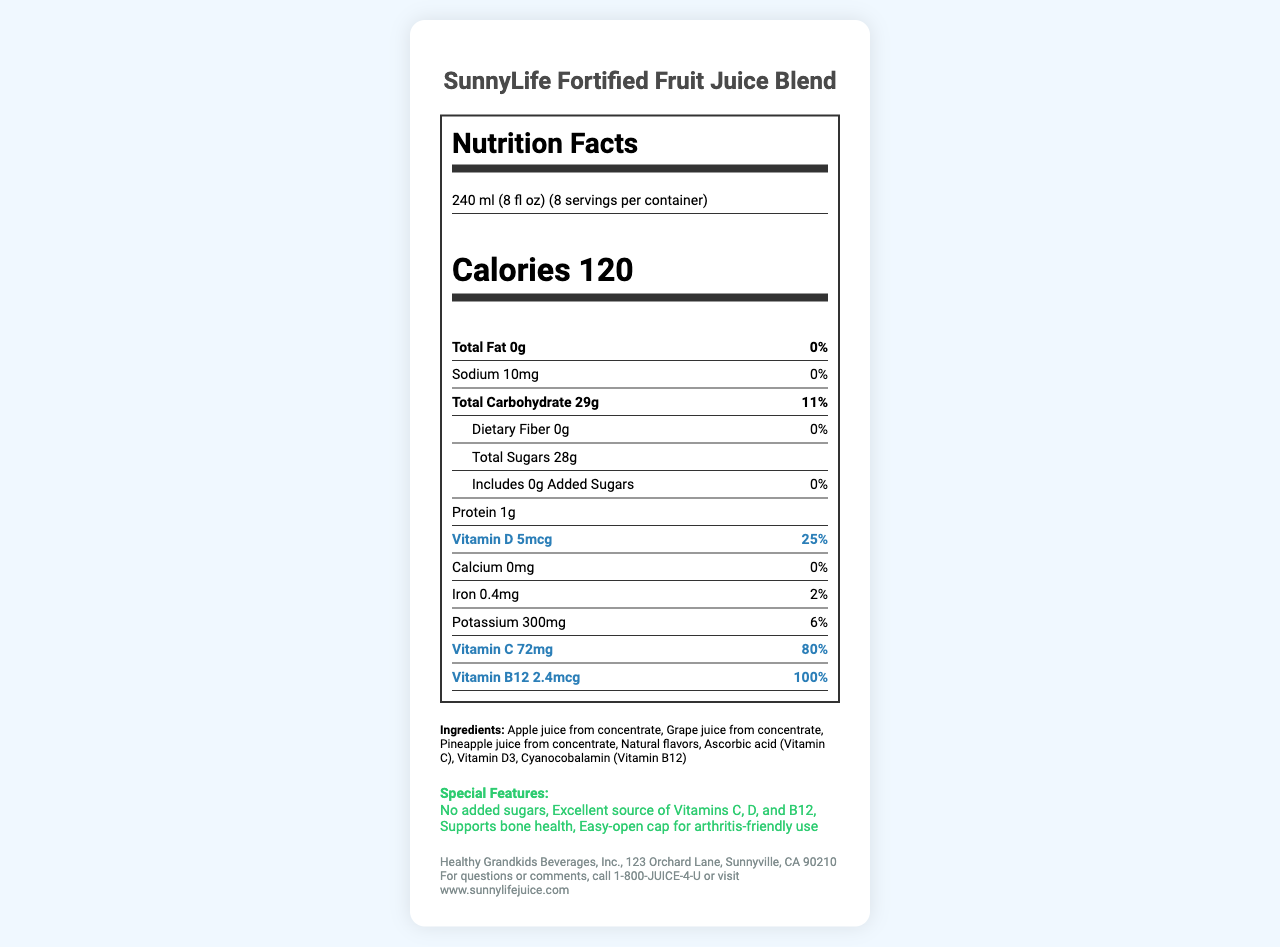what is the serving size for the SunnyLife Fortified Fruit Juice Blend? The document specifies that the serving size is 240 ml (8 fl oz).
Answer: 240 ml (8 fl oz) How many servings are there per container? According to the document, there are 8 servings per container.
Answer: 8 How many calories are in one serving of the juice? The document states that a serving has 120 calories.
Answer: 120 What is the daily value percentage for Vitamin C in each serving? The document shows that each serving provides 80% of the daily value for Vitamin C.
Answer: 80% Are there any added sugars in this juice? The document lists "addedSugars" as 0g with a daily value of 0%.
Answer: No Which vitamins are highlighted for their health benefits in the juice? A. Vitamin A and Vitamin E B. Vitamin C and Vitamin B6 C. Vitamin D and Vitamin B12 The document highlights Vitamin D and Vitamin B12 for their bone health benefits.
Answer: C How much sodium is in each serving of the juice? A. 0 mg B. 10 mg C. 5 mg The document indicates that each serving contains 10 mg of sodium.
Answer: B Is there any dietary fiber in this juice? According to the document, the dietary fiber amount is 0g.
Answer: No Does the juice support bone health? The document mentions that the juice supports bone health as one of its special features.
Answer: Yes How long should the juice be consumed after opening? The storage instructions specify that the juice should be consumed within 7 days after opening.
Answer: Within 7 days What are the total carbohydrates per serving? The document states that there are 29g of total carbohydrates per serving.
Answer: 29g Describe the main features of the SunnyLife Fortified Fruit Juice Blend. The document provides detailed information about the juice's nutrients, ingredients, special features, and storage instructions, emphasizing its vitamin content and bone health benefits.
Answer: The SunnyLife Fortified Fruit Juice Blend is a vitamin-fortified fruit juice that supports bone health and provides added vitamins B12 and D. It has no added sugars and is an excellent source of Vitamins C, D, and B12. Each serving contains 120 calories, 0g of fat, 10mg of sodium, 29g of carbohydrates, and 1g of protein. It is also arthritis-friendly and has a simple open cap. Where is Healthy Grandkids Beverages, Inc. located? The manufacturer info in the document specifies this address.
Answer: 123 Orchard Lane, Sunnyville, CA 90210 What is the source of the natural flavors used in the juice? The document lists "Natural flavors" as an ingredient but does not specify the source.
Answer: Not enough information What are the health benefits of vitamins B12 and D mentioned in the document? The document highlights that the added vitamins B12 and D support bone health.
Answer: Bone health 